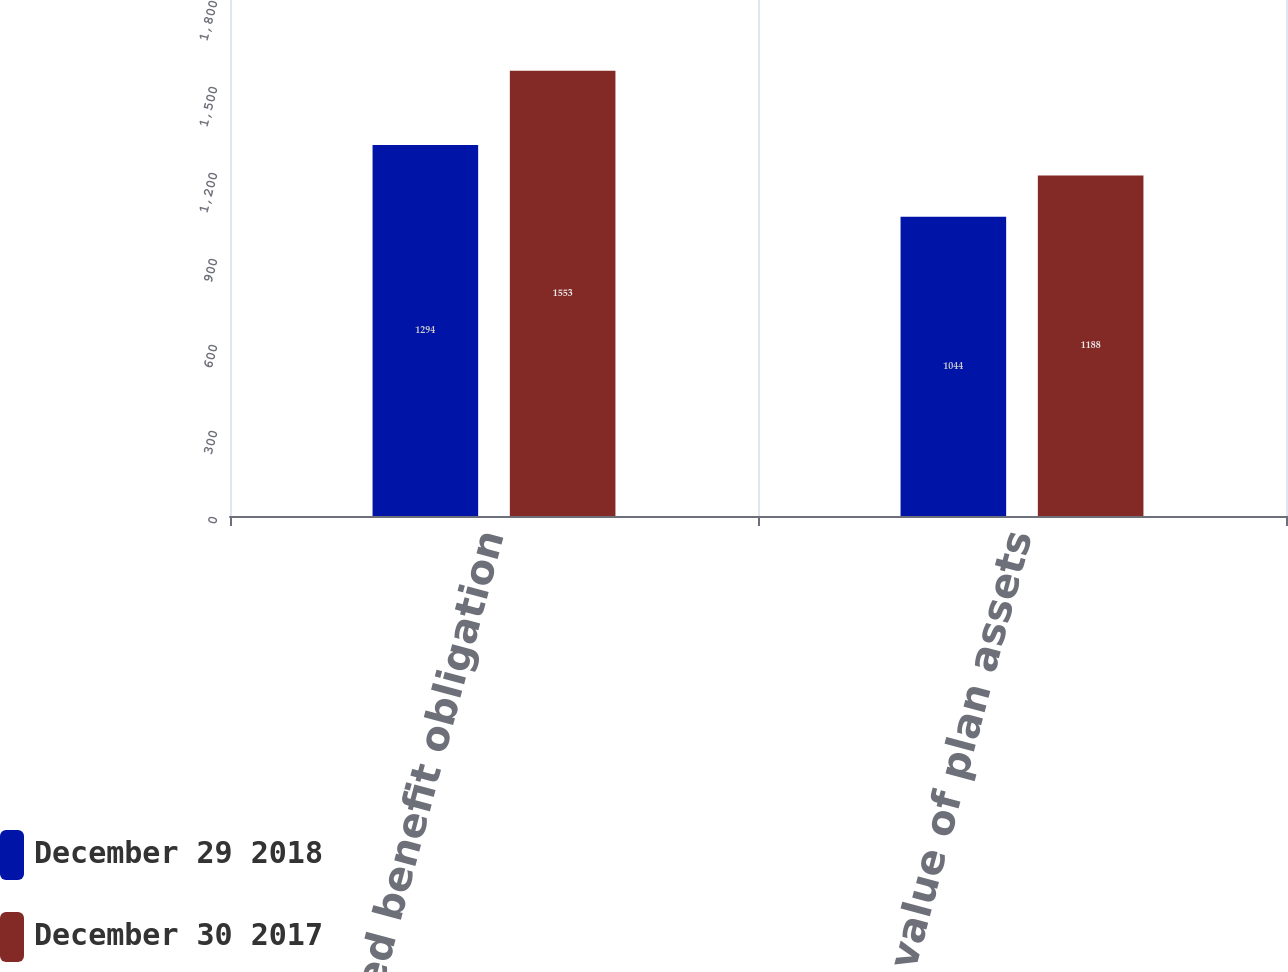<chart> <loc_0><loc_0><loc_500><loc_500><stacked_bar_chart><ecel><fcel>Accumulated benefit obligation<fcel>Fair value of plan assets<nl><fcel>December 29 2018<fcel>1294<fcel>1044<nl><fcel>December 30 2017<fcel>1553<fcel>1188<nl></chart> 